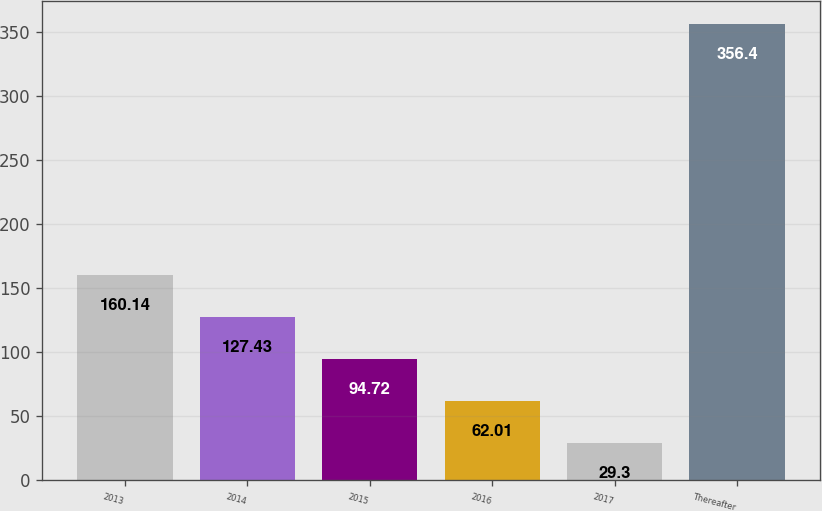Convert chart to OTSL. <chart><loc_0><loc_0><loc_500><loc_500><bar_chart><fcel>2013<fcel>2014<fcel>2015<fcel>2016<fcel>2017<fcel>Thereafter<nl><fcel>160.14<fcel>127.43<fcel>94.72<fcel>62.01<fcel>29.3<fcel>356.4<nl></chart> 